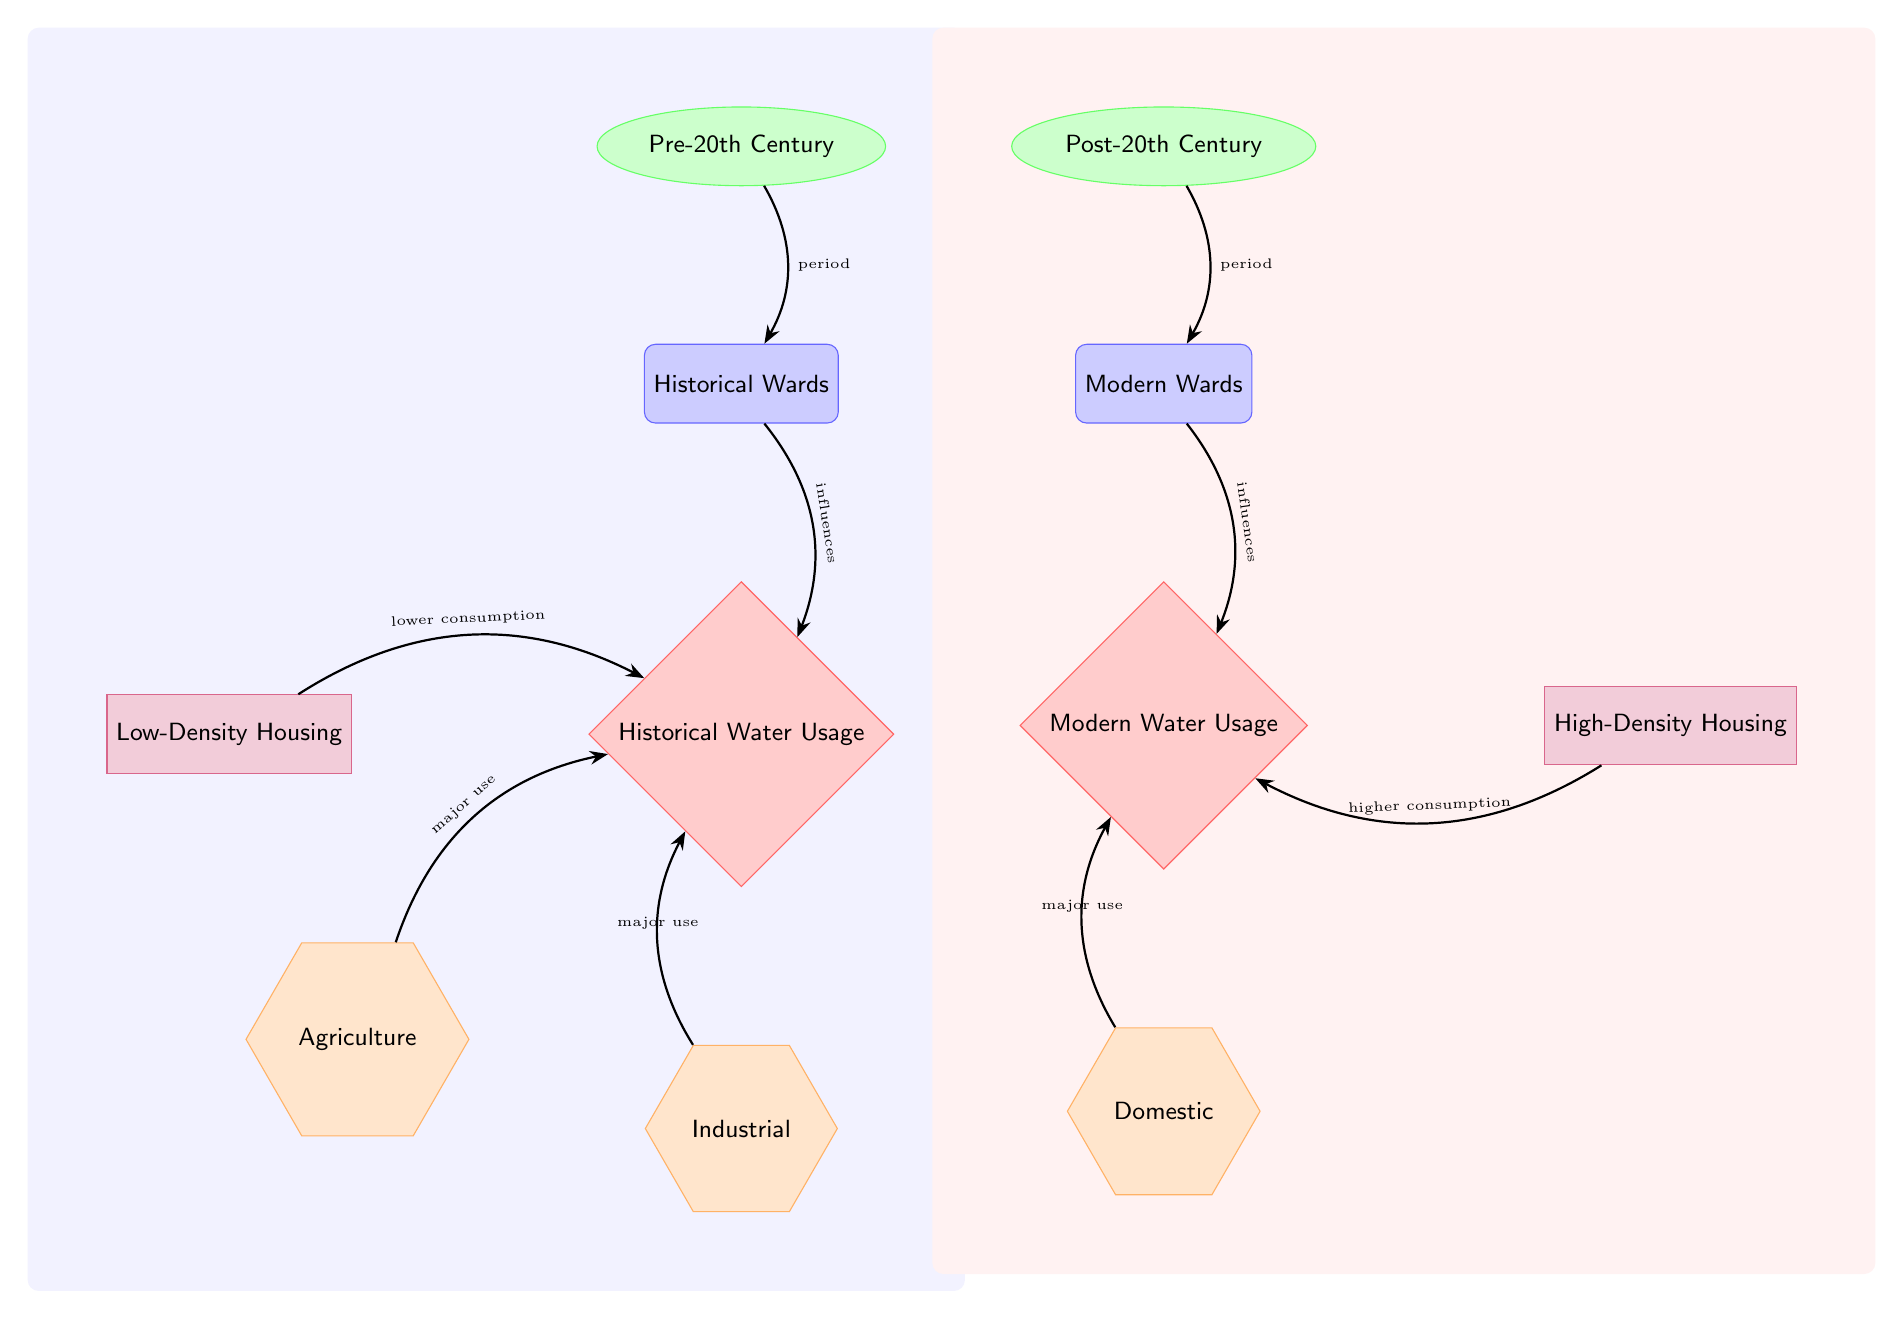What are the two periods represented in the diagram? The diagram shows two periods: Pre-20th Century and Post-20th Century. These periods are labeled at the top of the respective sections for historical and modern wards.
Answer: Pre-20th Century, Post-20th Century How does low-density housing affect historical water usage? The diagram indicates that low-density housing leads to lower water consumption for historical usage, connecting with an arrow pointing towards the historical water usage node.
Answer: Lower consumption Which type of major use is associated with modern water usage? The diagram specifies that domestic uses are the major category linked to modern water usage, as indicated by the arrow pointing to the modern usage node.
Answer: Domestic What influences modern water usage? The diagram states that modern wards influence modern water usage, with a direct arrow connecting the two nodes.
Answer: Modern wards How many sectors contribute to historical water usage? The diagram displays three sectors: agriculture, industrial, and domestic; therefore, the total number of sectors is three based on the connections to the historical usage node.
Answer: Three Which ward influences the higher consumption in modern water usage? The diagram shows that high-density housing is connected by an arrow that specifies higher consumption, making this the influencing factor for modern water usage.
Answer: High-density housing What is the relationship between agriculture and historical water usage? The diagram illustrates a direct connection from agriculture to historical usage, indicating that agriculture has a major influence on historical water consumption.
Answer: Major use What type of housing is linked to historical wards? The diagram indicates that low-density housing is associated with historical wards as it points towards the historical water usage node.
Answer: Low-density housing Identify the shape that represents modern wards in the diagram. The modern wards are represented by a rectangle with rounded corners, characterized by the style used in the diagram for ward nodes.
Answer: Rectangle 